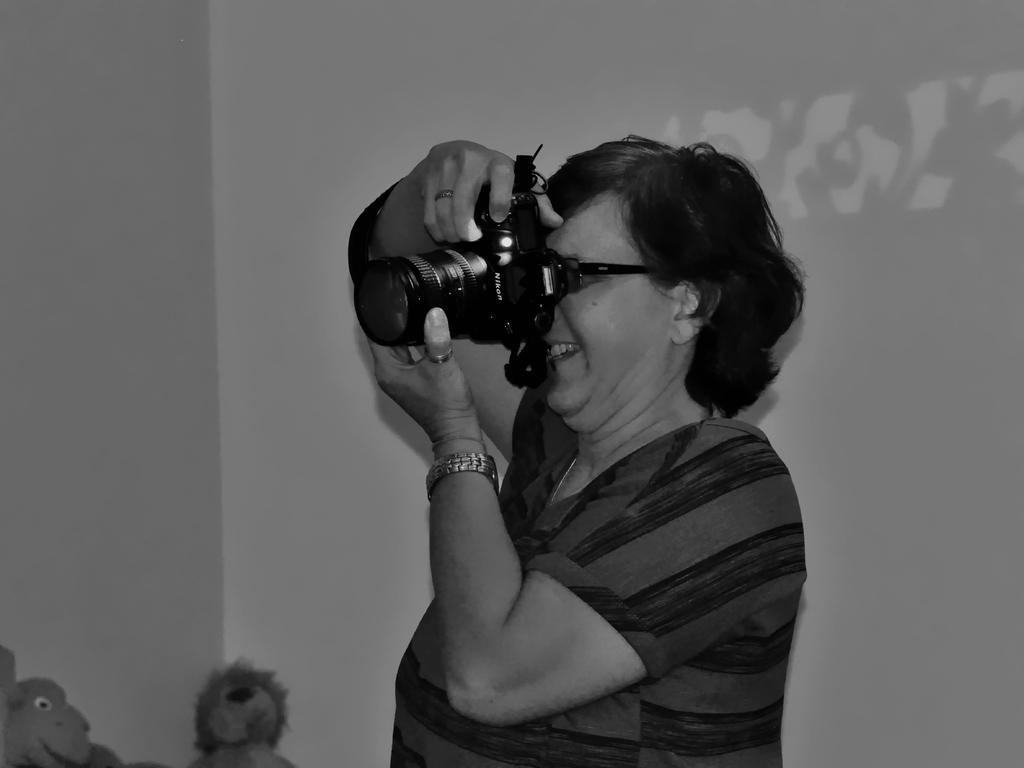Who is the main subject in the image? There is a woman in the image. What is the woman doing in the image? The woman is taking a photograph. What is the woman holding while taking the photograph? The woman is holding a digital camera. What can be seen in the background of the image? There are dolls and a wall in the background of the image. What type of bottle is being exchanged between the woman and the dolls in the image? There is no bottle present in the image, nor is there any exchange between the woman and the dolls. 